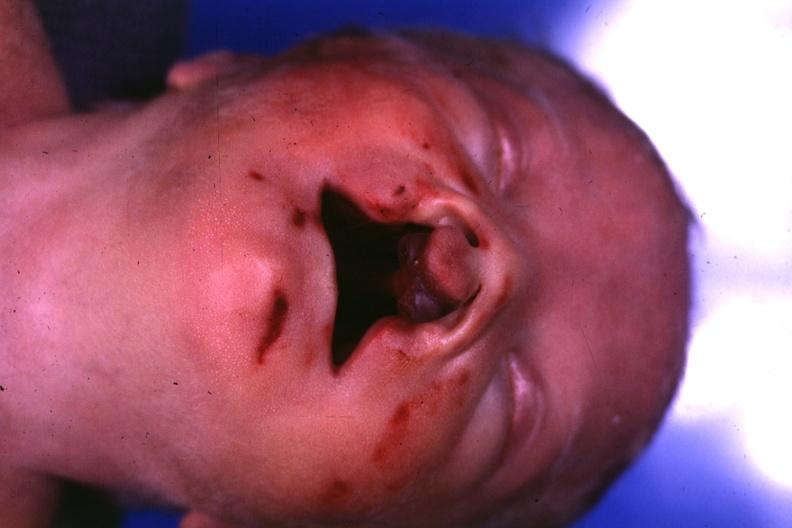s bilateral cleft palate present?
Answer the question using a single word or phrase. Yes 